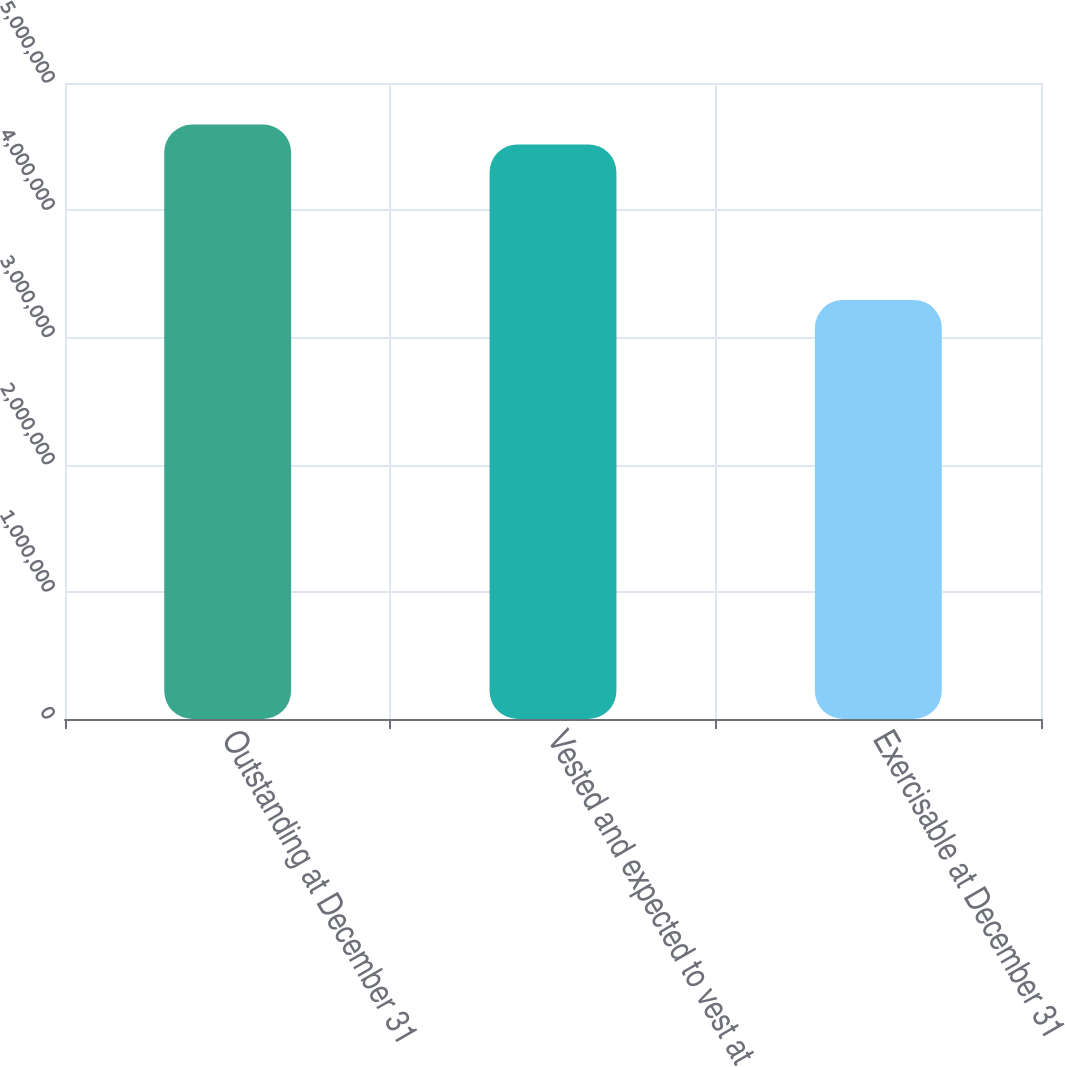Convert chart. <chart><loc_0><loc_0><loc_500><loc_500><bar_chart><fcel>Outstanding at December 31<fcel>Vested and expected to vest at<fcel>Exercisable at December 31<nl><fcel>4.67314e+06<fcel>4.51718e+06<fcel>3.29428e+06<nl></chart> 